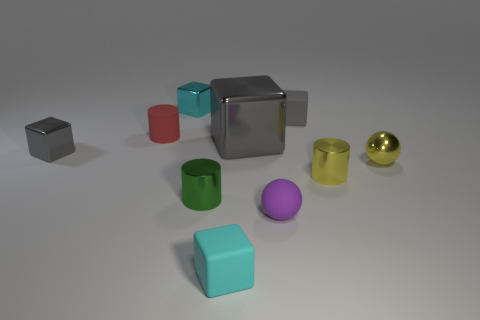Subtract all small metallic blocks. How many blocks are left? 3 Subtract all cyan blocks. How many blocks are left? 3 Add 9 tiny shiny balls. How many tiny shiny balls exist? 10 Subtract 0 cyan cylinders. How many objects are left? 10 Subtract all cylinders. How many objects are left? 7 Subtract 1 spheres. How many spheres are left? 1 Subtract all gray balls. Subtract all red cylinders. How many balls are left? 2 Subtract all yellow cylinders. How many red cubes are left? 0 Subtract all brown shiny cubes. Subtract all tiny green metallic cylinders. How many objects are left? 9 Add 5 matte cylinders. How many matte cylinders are left? 6 